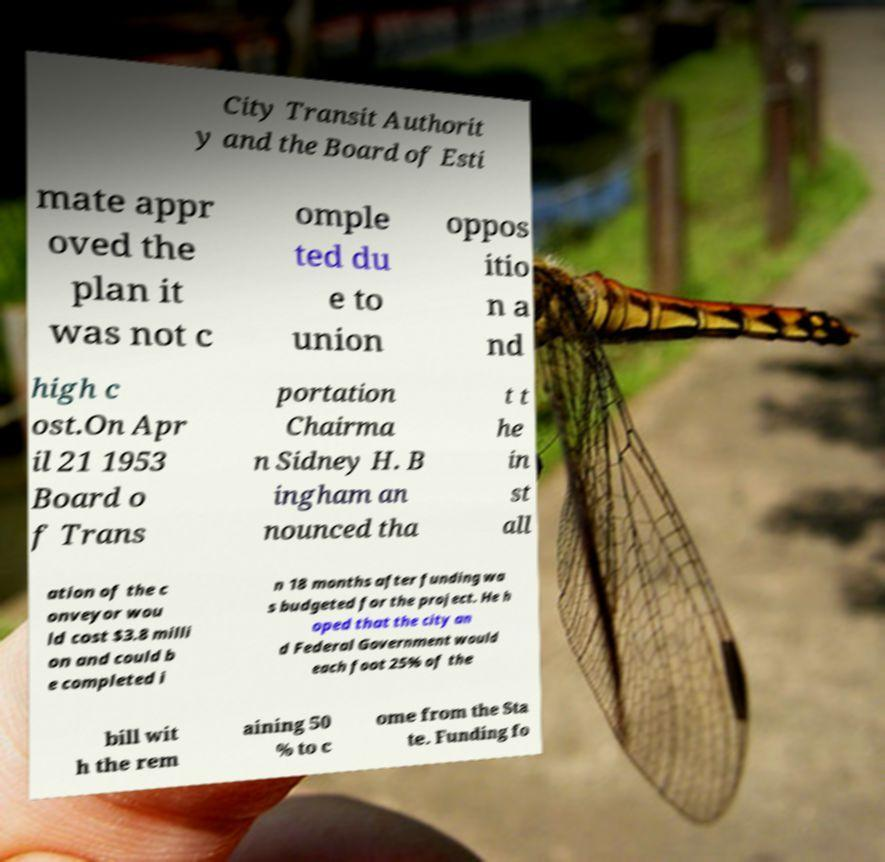I need the written content from this picture converted into text. Can you do that? City Transit Authorit y and the Board of Esti mate appr oved the plan it was not c omple ted du e to union oppos itio n a nd high c ost.On Apr il 21 1953 Board o f Trans portation Chairma n Sidney H. B ingham an nounced tha t t he in st all ation of the c onveyor wou ld cost $3.8 milli on and could b e completed i n 18 months after funding wa s budgeted for the project. He h oped that the city an d Federal Government would each foot 25% of the bill wit h the rem aining 50 % to c ome from the Sta te. Funding fo 